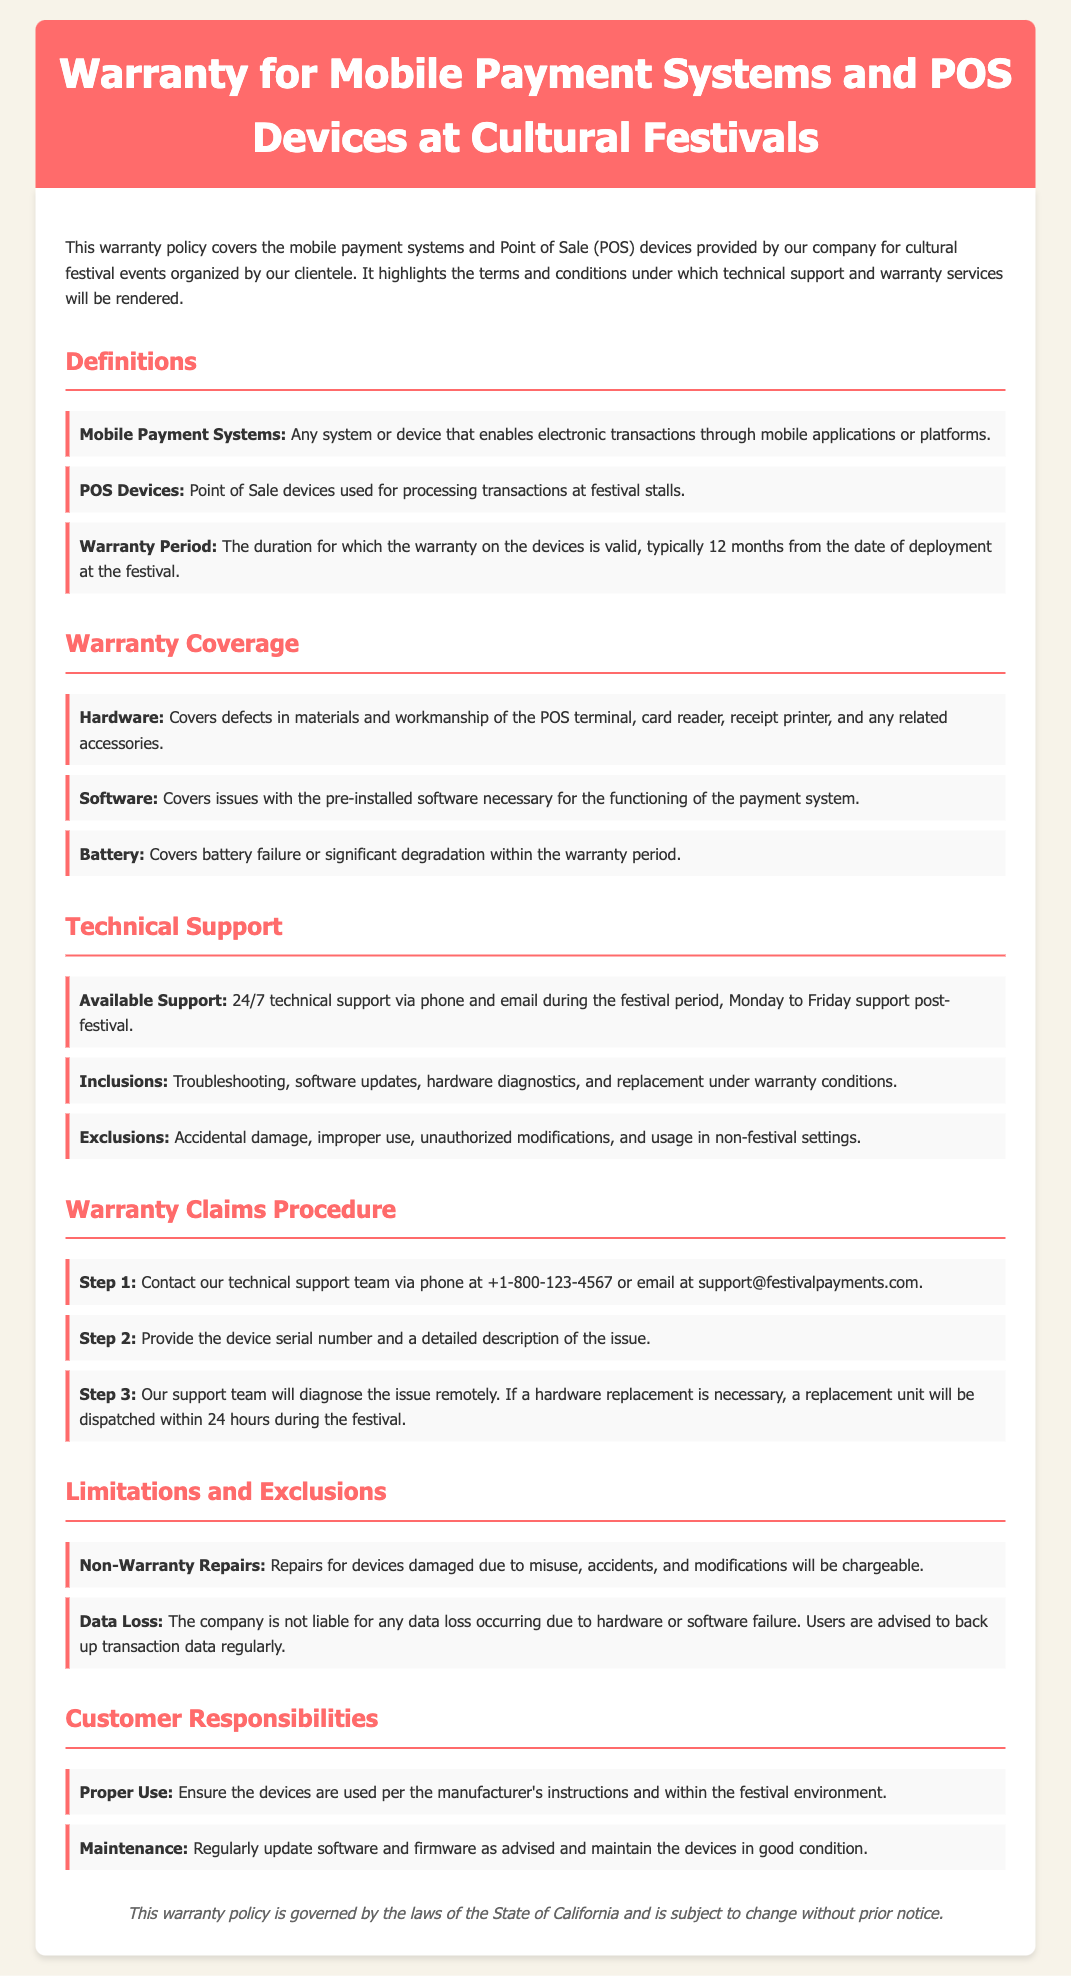What is the warranty period? The warranty period is the duration for which the warranty on the devices is valid, typically 12 months from the date of deployment at the festival.
Answer: 12 months What types of issues are covered under hardware warranty? The hardware warranty covers defects in materials and workmanship of the POS terminal, card reader, receipt printer, and any related accessories.
Answer: Defects in materials and workmanship What is included in the technical support? Inclusions for technical support cover troubleshooting, software updates, hardware diagnostics, and replacement under warranty conditions.
Answer: Troubleshooting, software updates, hardware diagnostics, and replacement What is the first step in the warranty claims procedure? The first step is to contact the technical support team via phone or email.
Answer: Contact technical support Which items are excluded from the warranty coverage? Exclusions include accidental damage, improper use, unauthorized modifications, and usage in non-festival settings.
Answer: Accidental damage, improper use, unauthorized modifications, usage in non-festival settings What should a customer do to maintain the device? Customers should regularly update software and firmware as advised and maintain the devices in good condition.
Answer: Regularly update software and firmware What phone number can be used for support? The number provided for technical support is +1-800-123-4567.
Answer: +1-800-123-4567 What action must a customer take to avoid data loss? Users are advised to back up transaction data regularly to avoid data loss.
Answer: Back up transaction data regularly 